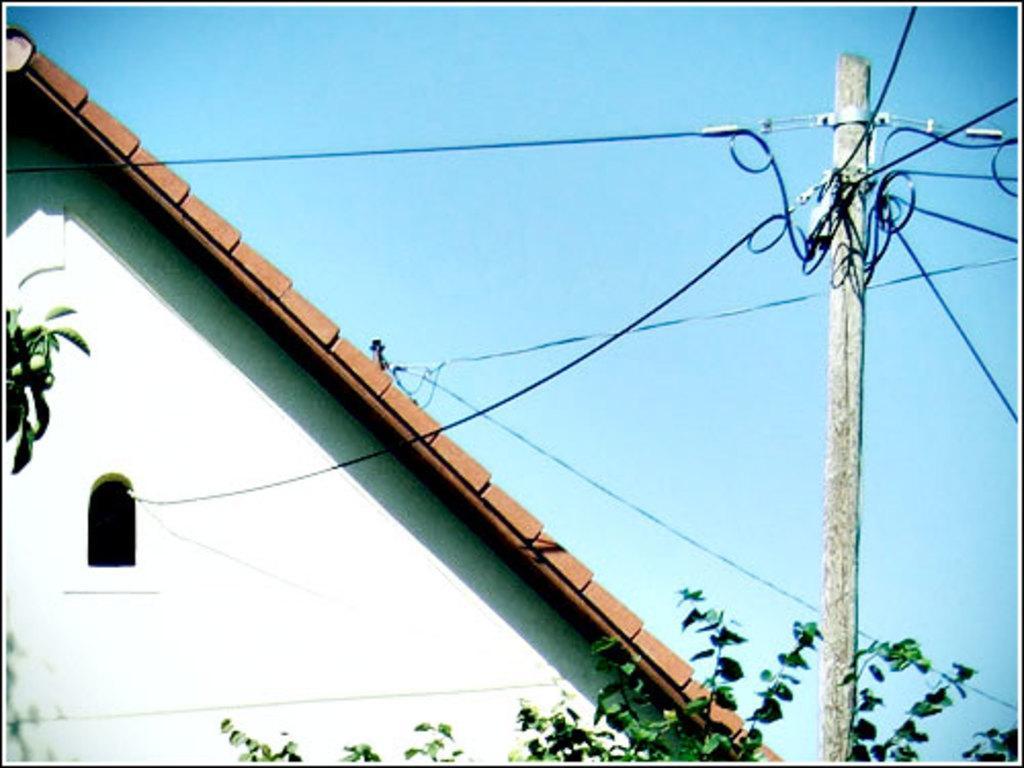In one or two sentences, can you explain what this image depicts? In this image we can see a building with window. In the foreground we can see a plant and a pole with cables on it. In the background, we can see the sky. 